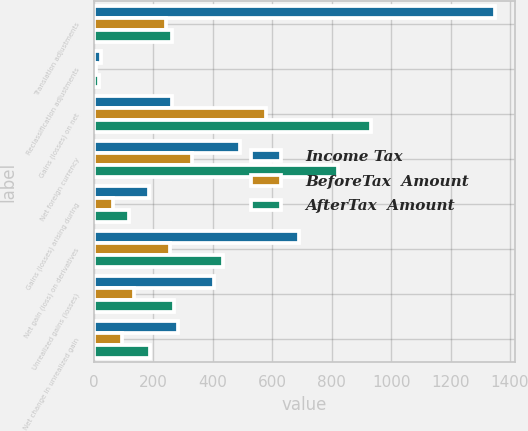Convert chart to OTSL. <chart><loc_0><loc_0><loc_500><loc_500><stacked_bar_chart><ecel><fcel>Translation adjustments<fcel>Reclassification adjustments<fcel>Gains (losses) on net<fcel>Net foreign currency<fcel>Gains (losses) arising during<fcel>Net gain (loss) on derivatives<fcel>Unrealized gains (losses)<fcel>Net change in unrealized gain<nl><fcel>Income Tax<fcel>1350<fcel>23<fcel>263<fcel>493<fcel>184<fcel>690<fcel>405<fcel>282<nl><fcel>BeforeTax  Amount<fcel>242<fcel>6<fcel>578<fcel>330<fcel>65<fcel>257<fcel>136<fcel>94<nl><fcel>AfterTax  Amount<fcel>263<fcel>17<fcel>934<fcel>823<fcel>119<fcel>433<fcel>269<fcel>188<nl></chart> 